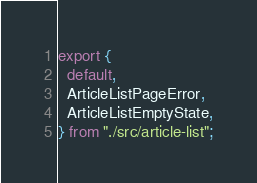<code> <loc_0><loc_0><loc_500><loc_500><_JavaScript_>export {
  default,
  ArticleListPageError,
  ArticleListEmptyState,
} from "./src/article-list";
</code> 